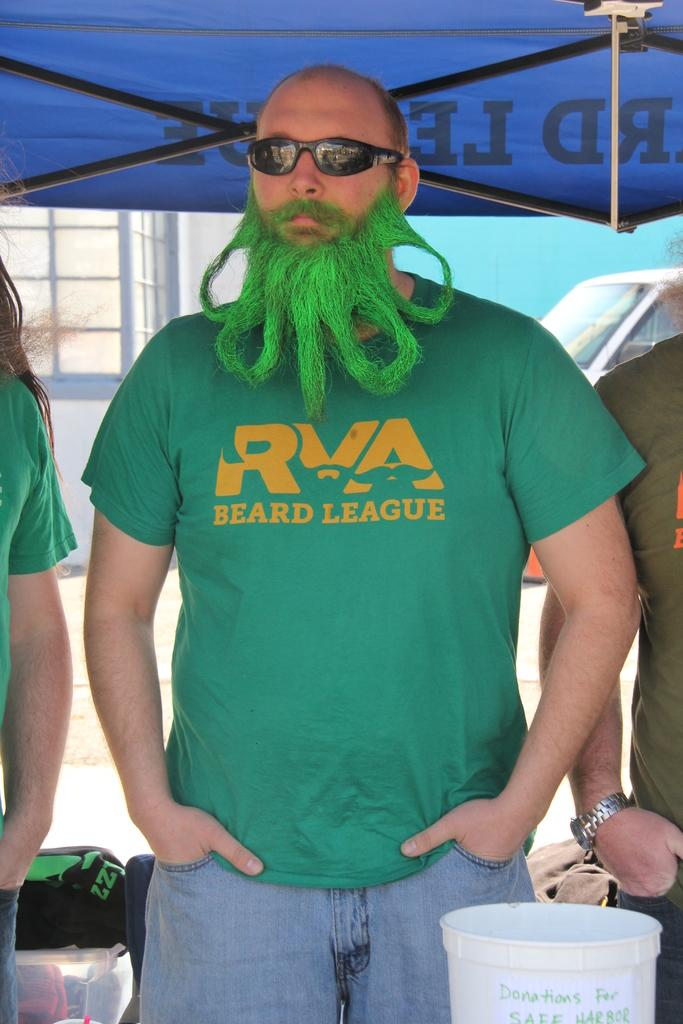<image>
Present a compact description of the photo's key features. A man with a green beard wears a RVA Beard League t-shirt. 